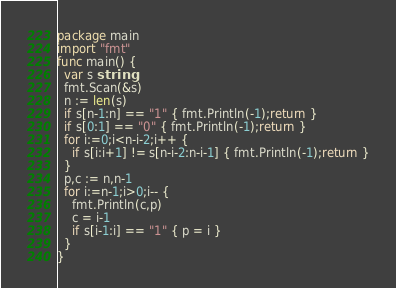Convert code to text. <code><loc_0><loc_0><loc_500><loc_500><_Go_>package main
import "fmt"
func main() {
  var s string
  fmt.Scan(&s)
  n := len(s)
  if s[n-1:n] == "1" { fmt.Println(-1);return }
  if s[0:1] == "0" { fmt.Println(-1);return }
  for i:=0;i<n-i-2;i++ {
    if s[i:i+1] != s[n-i-2:n-i-1] { fmt.Println(-1);return }
  }
  p,c := n,n-1
  for i:=n-1;i>0;i-- {
    fmt.Println(c,p)
    c = i-1
    if s[i-1:i] == "1" { p = i }
  }
}</code> 